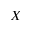<formula> <loc_0><loc_0><loc_500><loc_500>X</formula> 